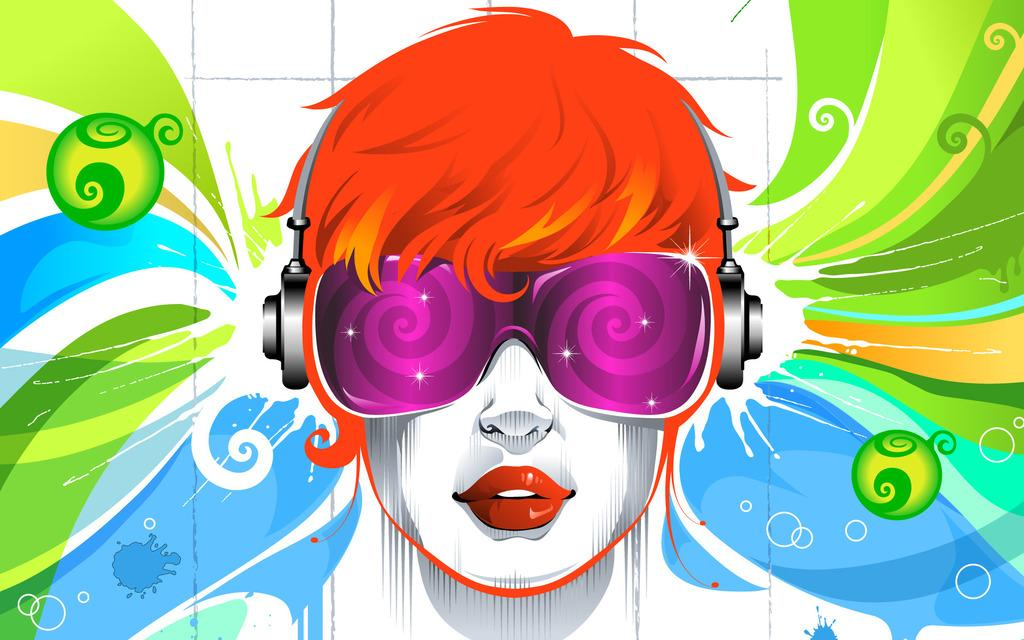What type of image is shown? The image is graphical in nature. Can you describe the person in the image? There is a person depicted in the image. What equipment is the person wearing? The person is wearing headsets and goggles. How many stalks of celery are being held by the person in the image? There is no celery present in the image; the person is wearing headsets and goggles. 